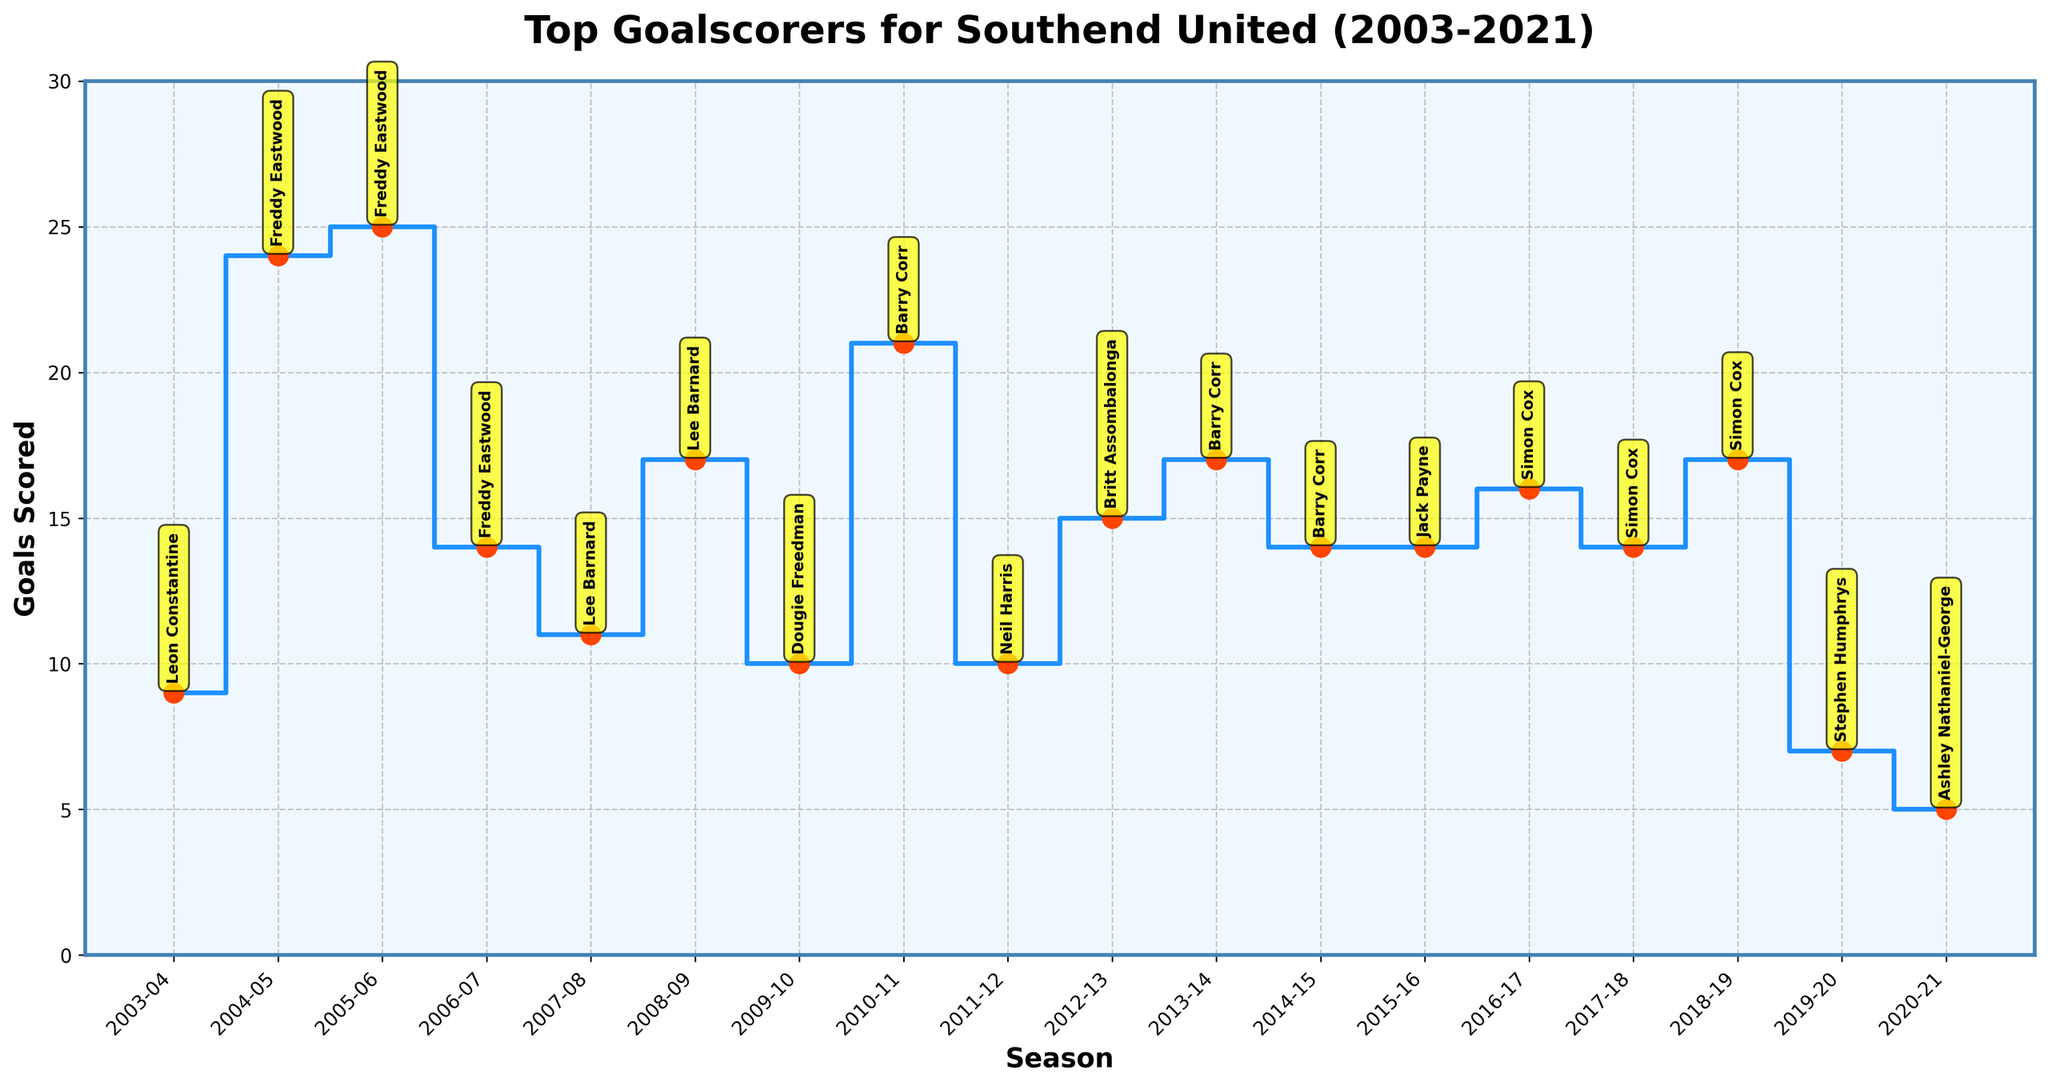What is the title of the figure? The title is displayed at the top of the chart, usually in a larger and bold font for emphasis.
Answer: Top Goalscorers for Southend United (2003-2021) What is the highest number of goals scored in a season and by whom? Look for the highest point on the step plot and note the corresponding player from the annotation.
Answer: Freddy Eastwood, 25 Which season saw the lowest top goalscorer and how many goals did they score? Identify the lowest point on the step plot and check the annotation for the season and player.
Answer: 2020-21, Emile Acquah, 4 goals How many seasons did Freddy Eastwood top the goalscoring chart for Southend United? Count each season where Freddy Eastwood was annotated as the top goalscorer.
Answer: 3 seasons What is the average number of goals scored by the top scorer across all seasons? Sum up the number of goals scored by the top scorers and divide by the total number of seasons. This requires averaging multiple values.
Answer: 10.05 Who scored the most goals in the 2012-2013 season? Find the annotation corresponding to the 2012-2013 season.
Answer: Britt Assombalonga Compare the top goalscorer's tally in 2014-2015 to that in 2018-2019. Which is higher and by how much? Identify the top scorers for each season and subtract the smaller number from the larger one to find the difference.
Answer: 2018-2019, Simon Cox scored 10 more goals than Barry Corr in 2014-2015 How many different players scored 10 or more goals as top goalscorers from 2003-2021? Count the annotations where the top scorer scored 10 or more goals.
Answer: 10 players How many players scored exactly 10 goals as top scorer in a season? Check the annotations for entries where the top goalscorer scored exactly 10 goals.
Answer: 4 players Which player scored the most goals in their top scoring season and how many did they score? Identify the player associated with the peak value on the step plot.
Answer: Freddy Eastwood, 25 goals 